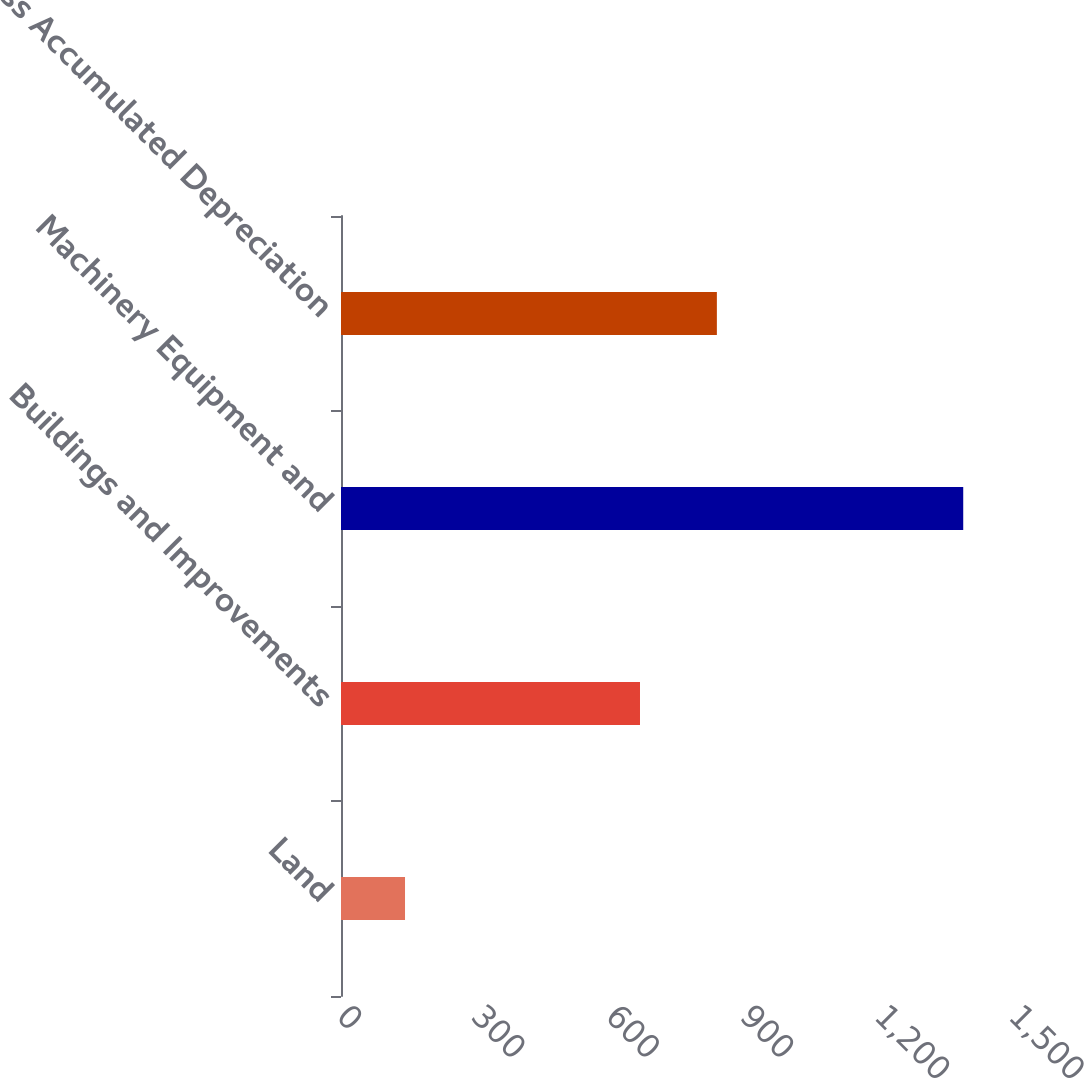<chart> <loc_0><loc_0><loc_500><loc_500><bar_chart><fcel>Land<fcel>Buildings and Improvements<fcel>Machinery Equipment and<fcel>Less Accumulated Depreciation<nl><fcel>142.9<fcel>667.4<fcel>1388.9<fcel>839<nl></chart> 